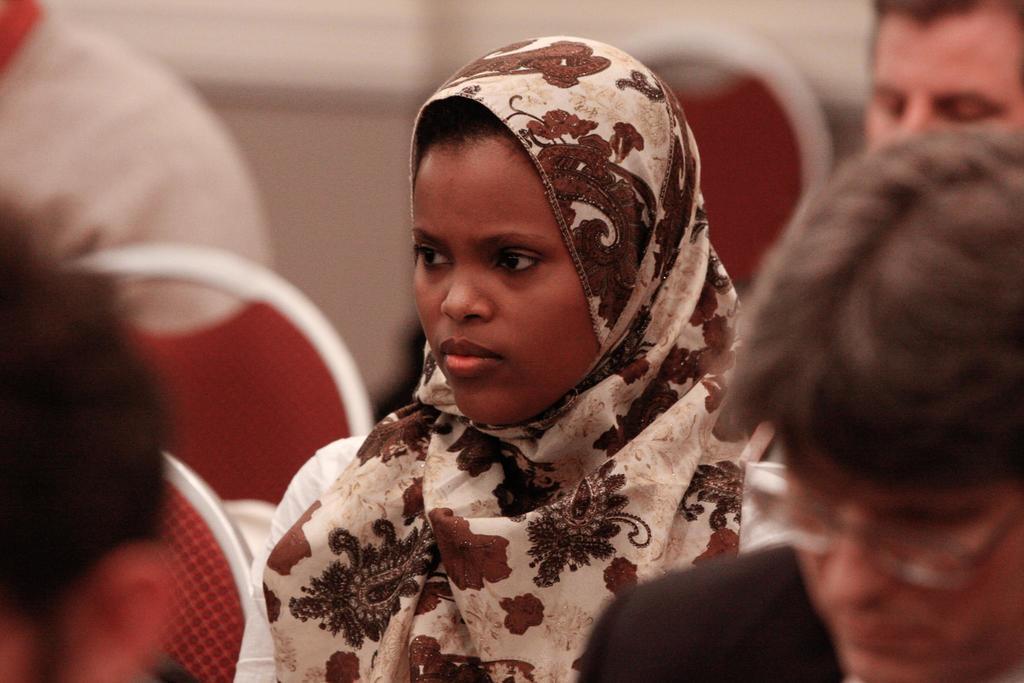How would you summarize this image in a sentence or two? In the foreground of this image, there are people sitting on the red chairs and the background image is blur. 